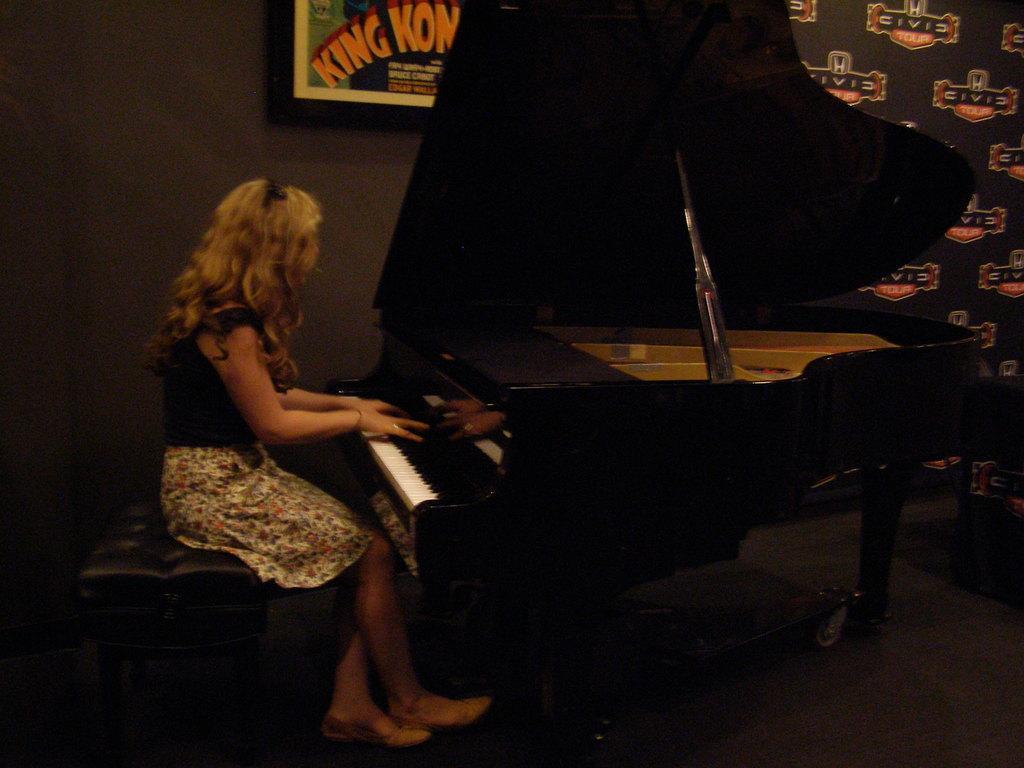Please provide a concise description of this image. In this image I can see a person sitting in-front of the piano. In the back there is a board to the wall. 